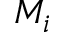<formula> <loc_0><loc_0><loc_500><loc_500>M _ { i }</formula> 